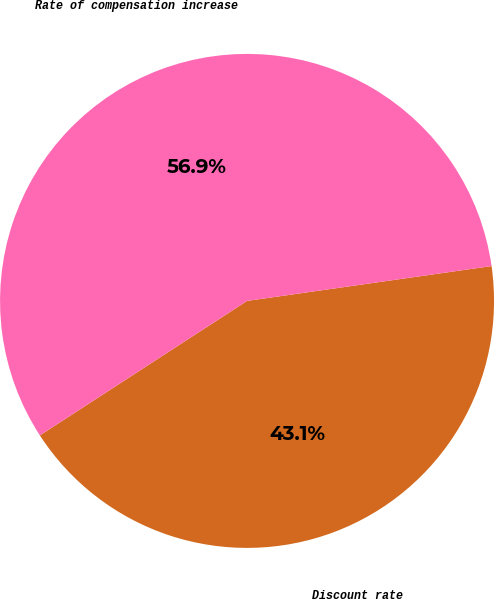Convert chart to OTSL. <chart><loc_0><loc_0><loc_500><loc_500><pie_chart><fcel>Discount rate<fcel>Rate of compensation increase<nl><fcel>43.09%<fcel>56.91%<nl></chart> 